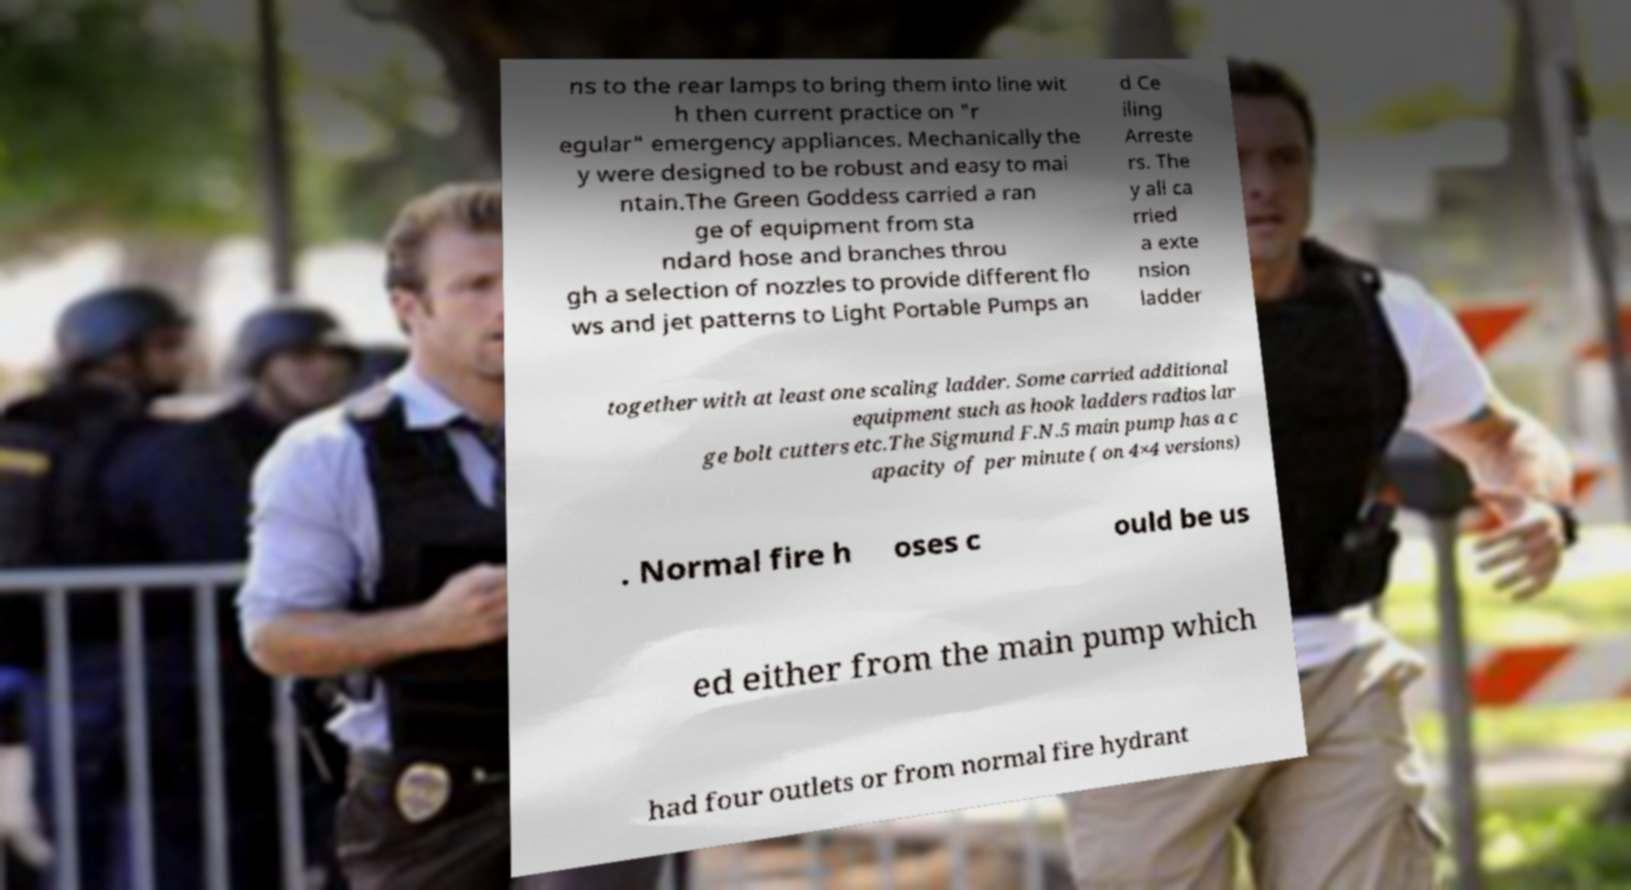For documentation purposes, I need the text within this image transcribed. Could you provide that? ns to the rear lamps to bring them into line wit h then current practice on "r egular" emergency appliances. Mechanically the y were designed to be robust and easy to mai ntain.The Green Goddess carried a ran ge of equipment from sta ndard hose and branches throu gh a selection of nozzles to provide different flo ws and jet patterns to Light Portable Pumps an d Ce iling Arreste rs. The y all ca rried a exte nsion ladder together with at least one scaling ladder. Some carried additional equipment such as hook ladders radios lar ge bolt cutters etc.The Sigmund F.N.5 main pump has a c apacity of per minute ( on 4×4 versions) . Normal fire h oses c ould be us ed either from the main pump which had four outlets or from normal fire hydrant 